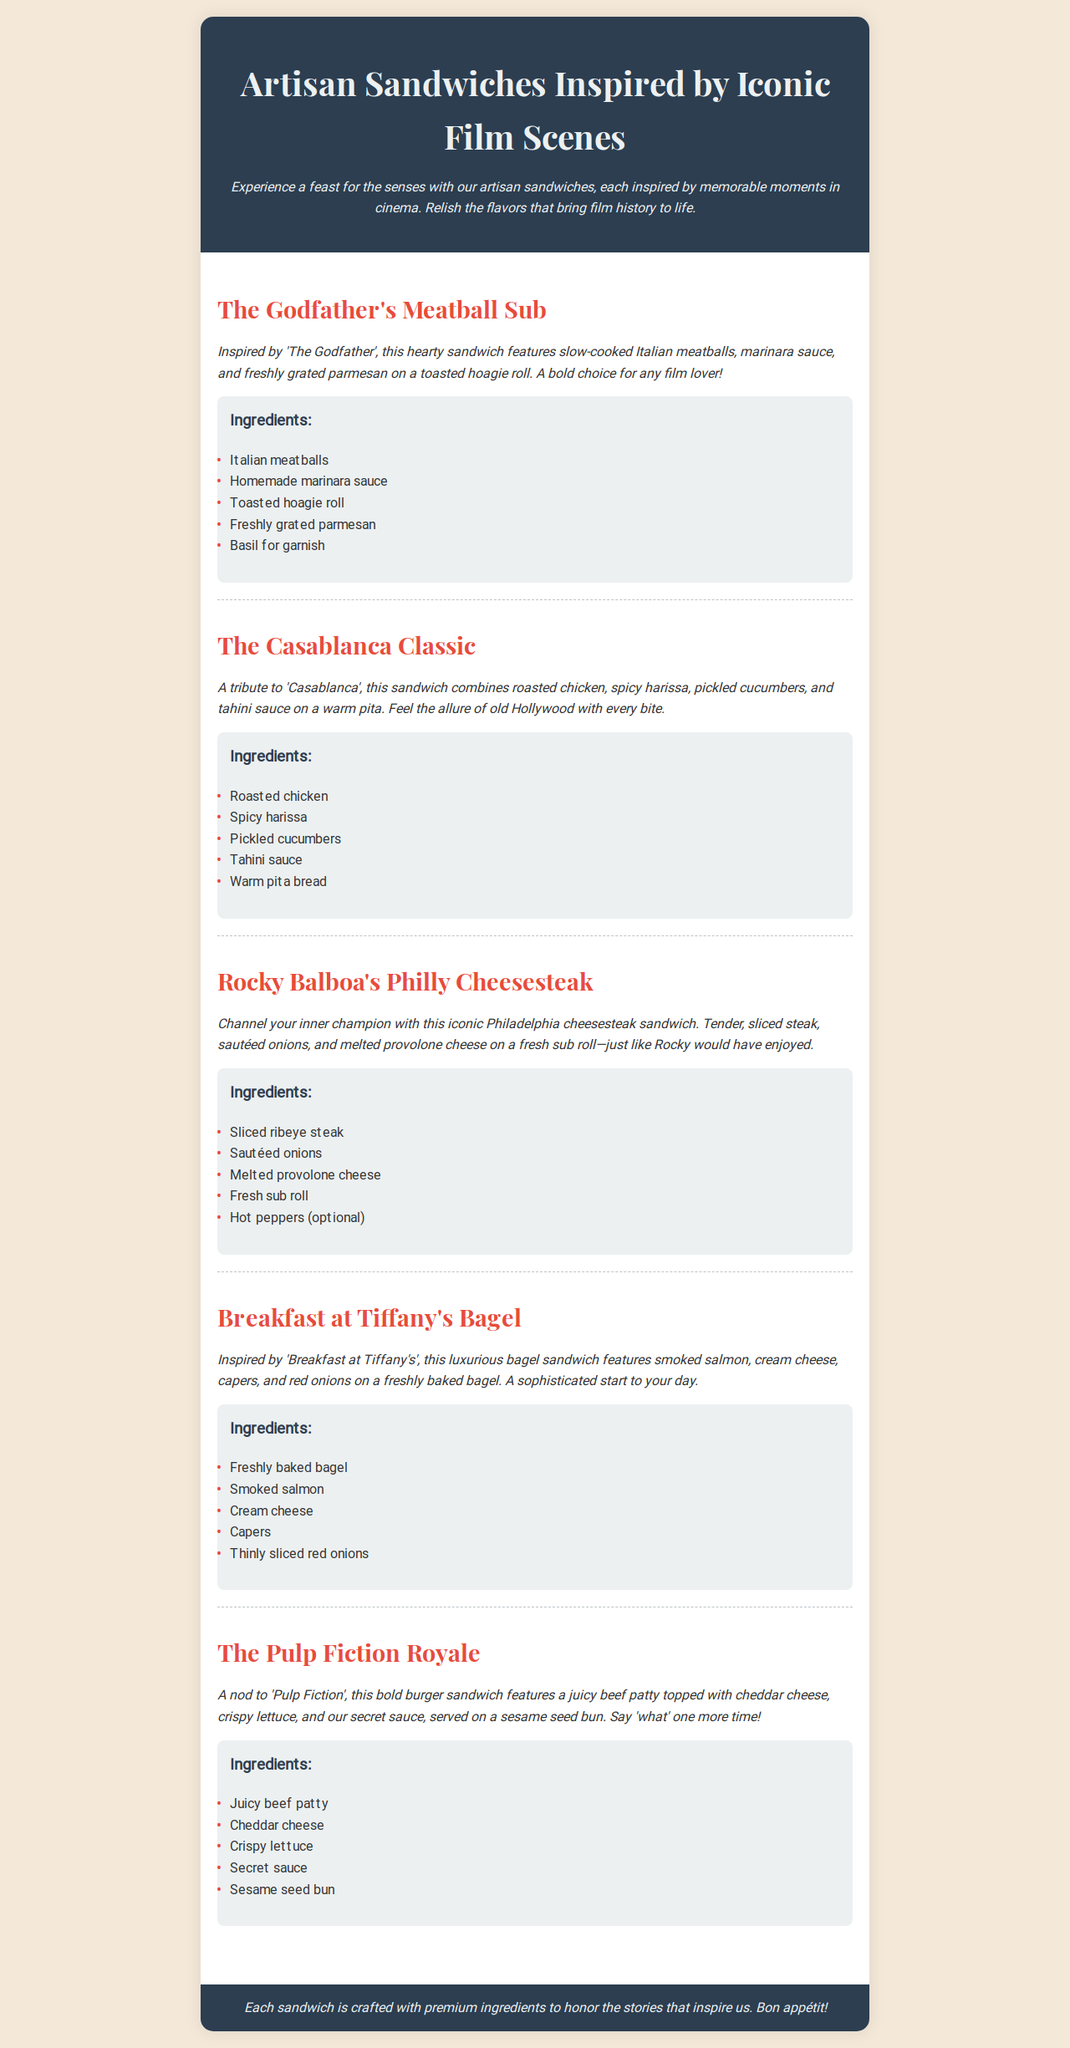what is the name of the first sandwich on the menu? The first sandwich listed is "The Godfather's Meatball Sub."
Answer: The Godfather's Meatball Sub which film inspired The Casablanca Classic? The Casablanca Classic is inspired by the film "Casablanca."
Answer: Casablanca how many ingredients are listed for Rocky Balboa's Philly Cheesesteak? There are five ingredients listed for Rocky Balboa's Philly Cheesesteak.
Answer: 5 what type of bread is used for the Breakfast at Tiffany's Bagel? The type of bread used is a freshly baked bagel.
Answer: freshly baked bagel which sandwich features a secret sauce? The sandwich that features a secret sauce is "The Pulp Fiction Royale."
Answer: The Pulp Fiction Royale what is the main protein in The Godfather's Meatball Sub? The main protein in The Godfather's Meatball Sub is Italian meatballs.
Answer: Italian meatballs how is the Casablanca Classic served? The Casablanca Classic is served on warm pita.
Answer: warm pita which sandwich includes smoked salmon as an ingredient? The sandwich that includes smoked salmon is "Breakfast at Tiffany's Bagel."
Answer: Breakfast at Tiffany's Bagel 